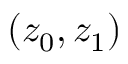<formula> <loc_0><loc_0><loc_500><loc_500>( z _ { 0 } , z _ { 1 } )</formula> 